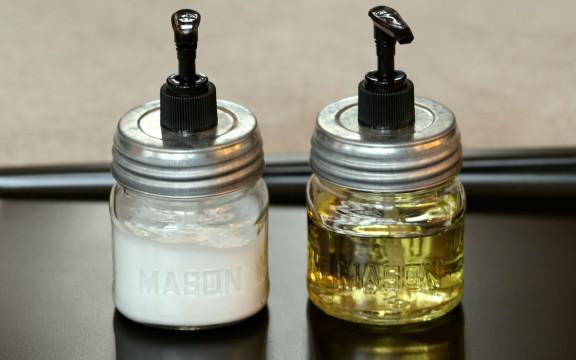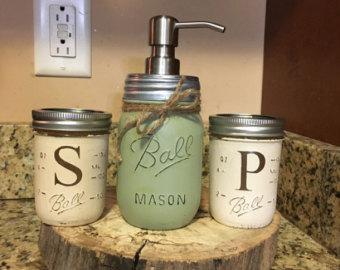The first image is the image on the left, the second image is the image on the right. Analyze the images presented: Is the assertion "One of the images shows at least one empty glass jar with a spout on top." valid? Answer yes or no. No. The first image is the image on the left, the second image is the image on the right. Assess this claim about the two images: "An image shows two opaque white dispensers side-by-side.". Correct or not? Answer yes or no. No. 